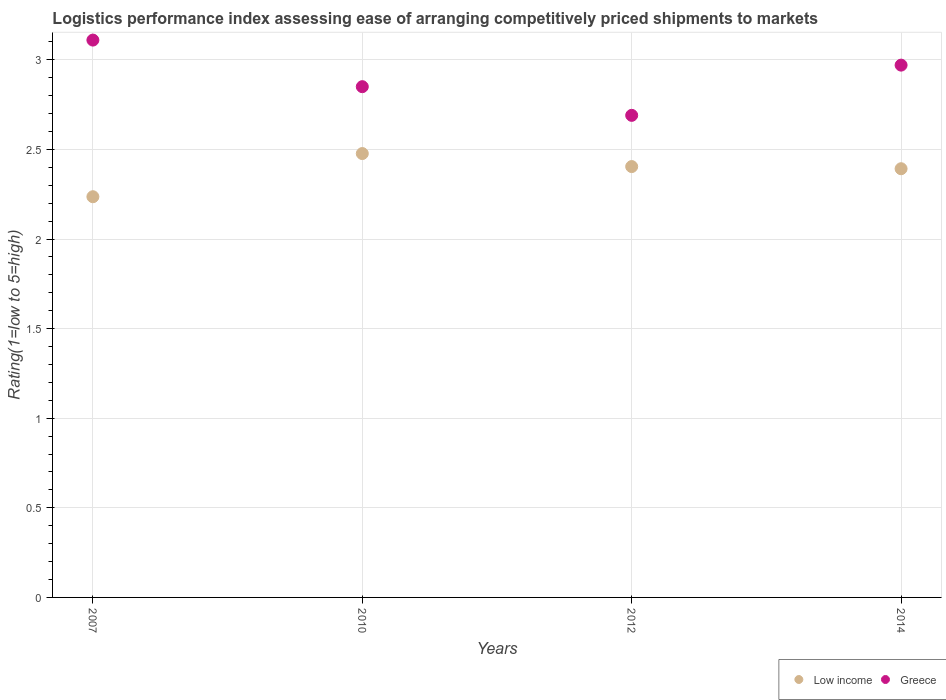Is the number of dotlines equal to the number of legend labels?
Your answer should be very brief. Yes. What is the Logistic performance index in Low income in 2012?
Your answer should be very brief. 2.4. Across all years, what is the maximum Logistic performance index in Low income?
Provide a succinct answer. 2.48. Across all years, what is the minimum Logistic performance index in Low income?
Your answer should be very brief. 2.24. In which year was the Logistic performance index in Low income maximum?
Ensure brevity in your answer.  2010. What is the total Logistic performance index in Greece in the graph?
Your answer should be very brief. 11.62. What is the difference between the Logistic performance index in Low income in 2007 and that in 2014?
Your response must be concise. -0.16. What is the difference between the Logistic performance index in Low income in 2014 and the Logistic performance index in Greece in 2012?
Give a very brief answer. -0.3. What is the average Logistic performance index in Low income per year?
Offer a terse response. 2.38. In the year 2014, what is the difference between the Logistic performance index in Low income and Logistic performance index in Greece?
Give a very brief answer. -0.58. In how many years, is the Logistic performance index in Low income greater than 1.2?
Give a very brief answer. 4. What is the ratio of the Logistic performance index in Greece in 2012 to that in 2014?
Provide a short and direct response. 0.91. Is the Logistic performance index in Low income in 2007 less than that in 2010?
Keep it short and to the point. Yes. What is the difference between the highest and the second highest Logistic performance index in Low income?
Your answer should be very brief. 0.07. What is the difference between the highest and the lowest Logistic performance index in Greece?
Give a very brief answer. 0.42. Is the sum of the Logistic performance index in Greece in 2007 and 2010 greater than the maximum Logistic performance index in Low income across all years?
Provide a succinct answer. Yes. Is the Logistic performance index in Greece strictly greater than the Logistic performance index in Low income over the years?
Make the answer very short. Yes. Is the Logistic performance index in Low income strictly less than the Logistic performance index in Greece over the years?
Provide a succinct answer. Yes. How many dotlines are there?
Offer a very short reply. 2. How many years are there in the graph?
Provide a succinct answer. 4. Are the values on the major ticks of Y-axis written in scientific E-notation?
Keep it short and to the point. No. Where does the legend appear in the graph?
Provide a succinct answer. Bottom right. How many legend labels are there?
Your answer should be compact. 2. How are the legend labels stacked?
Provide a succinct answer. Horizontal. What is the title of the graph?
Your answer should be compact. Logistics performance index assessing ease of arranging competitively priced shipments to markets. Does "St. Lucia" appear as one of the legend labels in the graph?
Ensure brevity in your answer.  No. What is the label or title of the X-axis?
Your answer should be compact. Years. What is the label or title of the Y-axis?
Your answer should be very brief. Rating(1=low to 5=high). What is the Rating(1=low to 5=high) of Low income in 2007?
Offer a very short reply. 2.24. What is the Rating(1=low to 5=high) in Greece in 2007?
Ensure brevity in your answer.  3.11. What is the Rating(1=low to 5=high) in Low income in 2010?
Offer a terse response. 2.48. What is the Rating(1=low to 5=high) of Greece in 2010?
Offer a very short reply. 2.85. What is the Rating(1=low to 5=high) of Low income in 2012?
Offer a terse response. 2.4. What is the Rating(1=low to 5=high) in Greece in 2012?
Keep it short and to the point. 2.69. What is the Rating(1=low to 5=high) of Low income in 2014?
Your response must be concise. 2.39. What is the Rating(1=low to 5=high) of Greece in 2014?
Ensure brevity in your answer.  2.97. Across all years, what is the maximum Rating(1=low to 5=high) in Low income?
Make the answer very short. 2.48. Across all years, what is the maximum Rating(1=low to 5=high) in Greece?
Your answer should be very brief. 3.11. Across all years, what is the minimum Rating(1=low to 5=high) in Low income?
Offer a very short reply. 2.24. Across all years, what is the minimum Rating(1=low to 5=high) in Greece?
Provide a short and direct response. 2.69. What is the total Rating(1=low to 5=high) of Low income in the graph?
Give a very brief answer. 9.51. What is the total Rating(1=low to 5=high) of Greece in the graph?
Ensure brevity in your answer.  11.62. What is the difference between the Rating(1=low to 5=high) of Low income in 2007 and that in 2010?
Give a very brief answer. -0.24. What is the difference between the Rating(1=low to 5=high) in Greece in 2007 and that in 2010?
Make the answer very short. 0.26. What is the difference between the Rating(1=low to 5=high) in Low income in 2007 and that in 2012?
Make the answer very short. -0.17. What is the difference between the Rating(1=low to 5=high) in Greece in 2007 and that in 2012?
Give a very brief answer. 0.42. What is the difference between the Rating(1=low to 5=high) in Low income in 2007 and that in 2014?
Keep it short and to the point. -0.16. What is the difference between the Rating(1=low to 5=high) of Greece in 2007 and that in 2014?
Offer a terse response. 0.14. What is the difference between the Rating(1=low to 5=high) in Low income in 2010 and that in 2012?
Provide a succinct answer. 0.07. What is the difference between the Rating(1=low to 5=high) of Greece in 2010 and that in 2012?
Your answer should be very brief. 0.16. What is the difference between the Rating(1=low to 5=high) of Low income in 2010 and that in 2014?
Make the answer very short. 0.08. What is the difference between the Rating(1=low to 5=high) of Greece in 2010 and that in 2014?
Your response must be concise. -0.12. What is the difference between the Rating(1=low to 5=high) in Low income in 2012 and that in 2014?
Make the answer very short. 0.01. What is the difference between the Rating(1=low to 5=high) of Greece in 2012 and that in 2014?
Your answer should be very brief. -0.28. What is the difference between the Rating(1=low to 5=high) of Low income in 2007 and the Rating(1=low to 5=high) of Greece in 2010?
Provide a short and direct response. -0.61. What is the difference between the Rating(1=low to 5=high) of Low income in 2007 and the Rating(1=low to 5=high) of Greece in 2012?
Provide a succinct answer. -0.45. What is the difference between the Rating(1=low to 5=high) of Low income in 2007 and the Rating(1=low to 5=high) of Greece in 2014?
Your response must be concise. -0.73. What is the difference between the Rating(1=low to 5=high) in Low income in 2010 and the Rating(1=low to 5=high) in Greece in 2012?
Your answer should be compact. -0.21. What is the difference between the Rating(1=low to 5=high) of Low income in 2010 and the Rating(1=low to 5=high) of Greece in 2014?
Your answer should be very brief. -0.49. What is the difference between the Rating(1=low to 5=high) in Low income in 2012 and the Rating(1=low to 5=high) in Greece in 2014?
Provide a short and direct response. -0.57. What is the average Rating(1=low to 5=high) of Low income per year?
Offer a terse response. 2.38. What is the average Rating(1=low to 5=high) of Greece per year?
Provide a succinct answer. 2.91. In the year 2007, what is the difference between the Rating(1=low to 5=high) of Low income and Rating(1=low to 5=high) of Greece?
Provide a short and direct response. -0.87. In the year 2010, what is the difference between the Rating(1=low to 5=high) of Low income and Rating(1=low to 5=high) of Greece?
Offer a terse response. -0.37. In the year 2012, what is the difference between the Rating(1=low to 5=high) in Low income and Rating(1=low to 5=high) in Greece?
Give a very brief answer. -0.29. In the year 2014, what is the difference between the Rating(1=low to 5=high) in Low income and Rating(1=low to 5=high) in Greece?
Make the answer very short. -0.58. What is the ratio of the Rating(1=low to 5=high) in Low income in 2007 to that in 2010?
Make the answer very short. 0.9. What is the ratio of the Rating(1=low to 5=high) in Greece in 2007 to that in 2010?
Keep it short and to the point. 1.09. What is the ratio of the Rating(1=low to 5=high) in Low income in 2007 to that in 2012?
Ensure brevity in your answer.  0.93. What is the ratio of the Rating(1=low to 5=high) of Greece in 2007 to that in 2012?
Offer a very short reply. 1.16. What is the ratio of the Rating(1=low to 5=high) in Low income in 2007 to that in 2014?
Offer a terse response. 0.93. What is the ratio of the Rating(1=low to 5=high) in Greece in 2007 to that in 2014?
Offer a very short reply. 1.05. What is the ratio of the Rating(1=low to 5=high) of Low income in 2010 to that in 2012?
Your response must be concise. 1.03. What is the ratio of the Rating(1=low to 5=high) of Greece in 2010 to that in 2012?
Provide a short and direct response. 1.06. What is the ratio of the Rating(1=low to 5=high) of Low income in 2010 to that in 2014?
Provide a succinct answer. 1.04. What is the ratio of the Rating(1=low to 5=high) of Greece in 2010 to that in 2014?
Offer a terse response. 0.96. What is the ratio of the Rating(1=low to 5=high) in Greece in 2012 to that in 2014?
Your answer should be very brief. 0.91. What is the difference between the highest and the second highest Rating(1=low to 5=high) of Low income?
Offer a terse response. 0.07. What is the difference between the highest and the second highest Rating(1=low to 5=high) in Greece?
Provide a short and direct response. 0.14. What is the difference between the highest and the lowest Rating(1=low to 5=high) of Low income?
Offer a very short reply. 0.24. What is the difference between the highest and the lowest Rating(1=low to 5=high) in Greece?
Your answer should be compact. 0.42. 